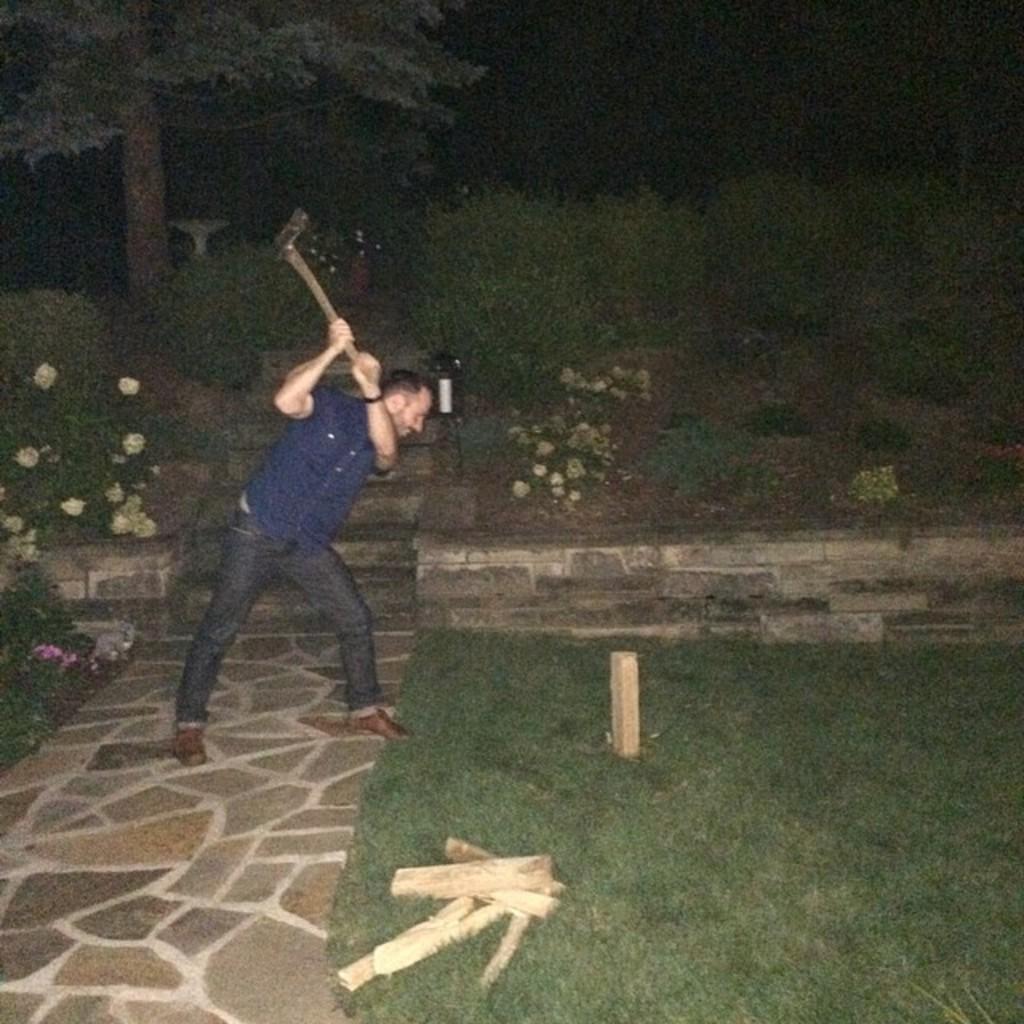Can you describe this image briefly? In this image I can see the person and the person is holding some object. The person is wearing blue and black color dress, background I can see few flowers in cream and pink color and I can also see few wooden logs and few trees in green color. 